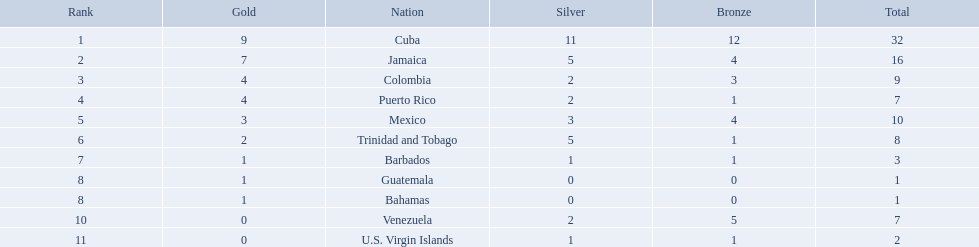Would you mind parsing the complete table? {'header': ['Rank', 'Gold', 'Nation', 'Silver', 'Bronze', 'Total'], 'rows': [['1', '9', 'Cuba', '11', '12', '32'], ['2', '7', 'Jamaica', '5', '4', '16'], ['3', '4', 'Colombia', '2', '3', '9'], ['4', '4', 'Puerto Rico', '2', '1', '7'], ['5', '3', 'Mexico', '3', '4', '10'], ['6', '2', 'Trinidad and Tobago', '5', '1', '8'], ['7', '1', 'Barbados', '1', '1', '3'], ['8', '1', 'Guatemala', '0', '0', '1'], ['8', '1', 'Bahamas', '0', '0', '1'], ['10', '0', 'Venezuela', '2', '5', '7'], ['11', '0', 'U.S. Virgin Islands', '1', '1', '2']]} Which nations played in the games? Cuba, Jamaica, Colombia, Puerto Rico, Mexico, Trinidad and Tobago, Barbados, Guatemala, Bahamas, Venezuela, U.S. Virgin Islands. How many silver medals did they win? 11, 5, 2, 2, 3, 5, 1, 0, 0, 2, 1. Which team won the most silver? Cuba. What nation has won at least 4 gold medals? Cuba, Jamaica, Colombia, Puerto Rico. Of these countries who has won the least amount of bronze medals? Puerto Rico. What teams had four gold medals? Colombia, Puerto Rico. Of these two, which team only had one bronze medal? Puerto Rico. 